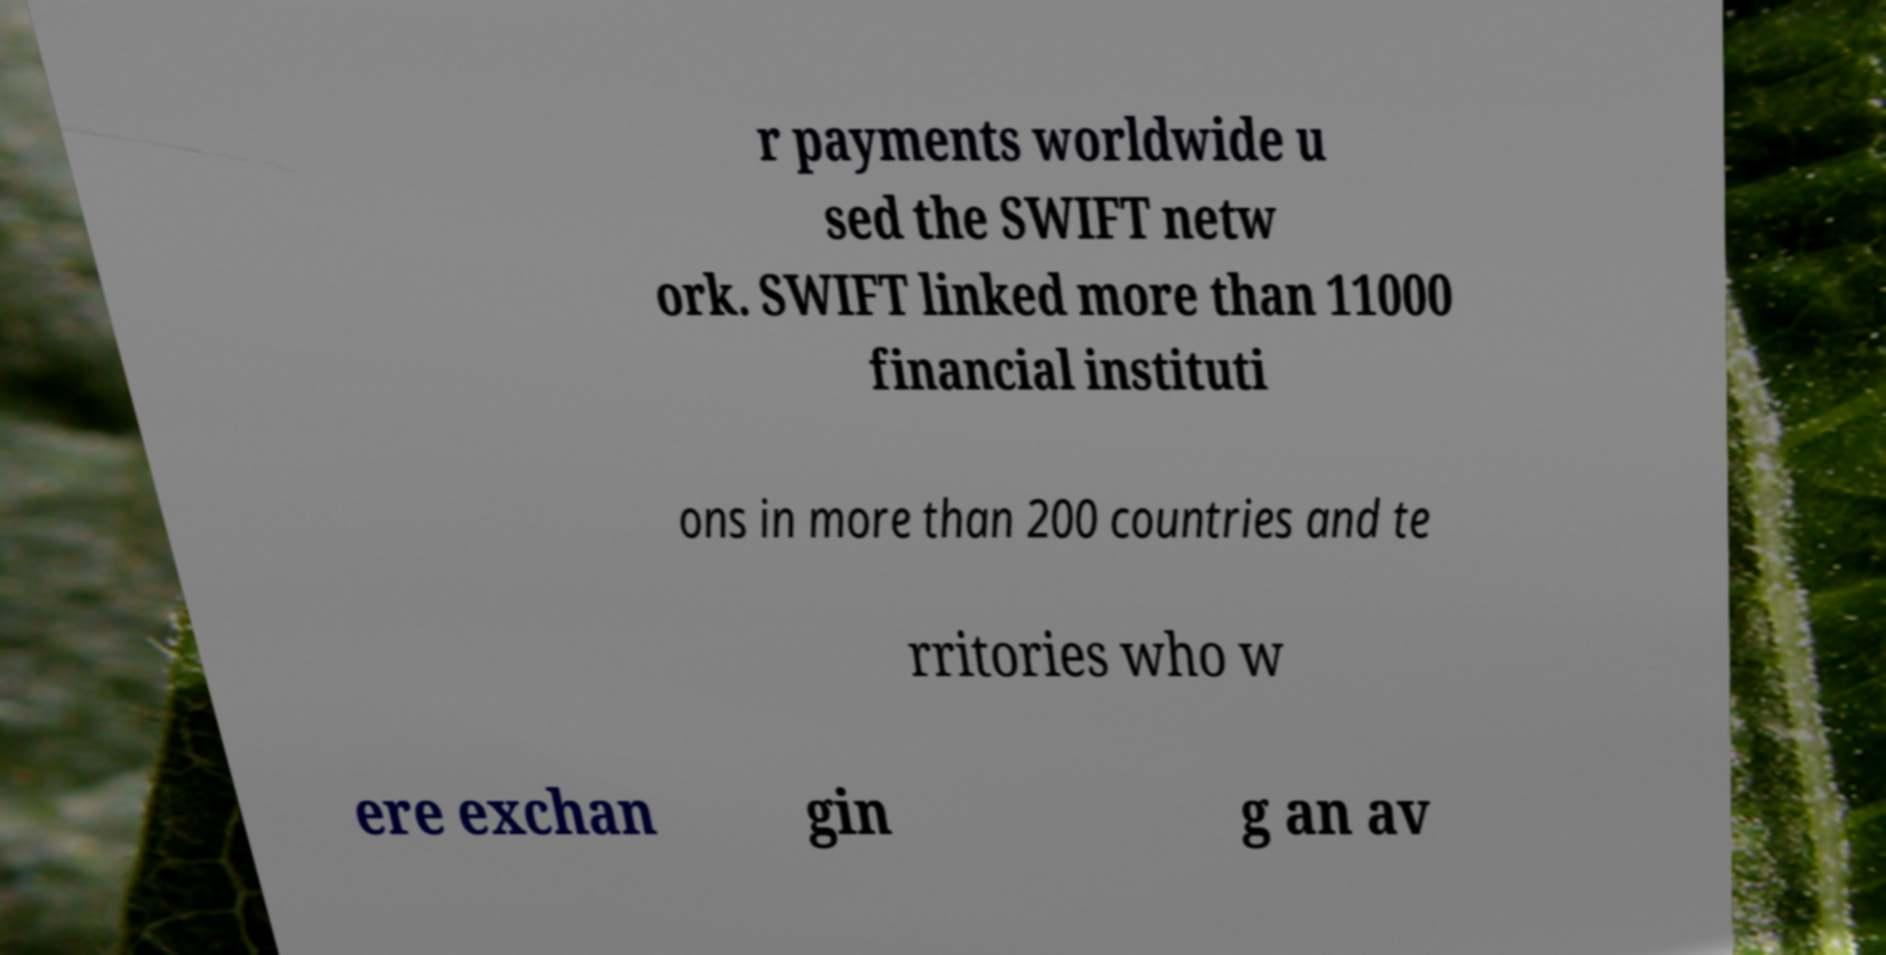For documentation purposes, I need the text within this image transcribed. Could you provide that? r payments worldwide u sed the SWIFT netw ork. SWIFT linked more than 11000 financial instituti ons in more than 200 countries and te rritories who w ere exchan gin g an av 